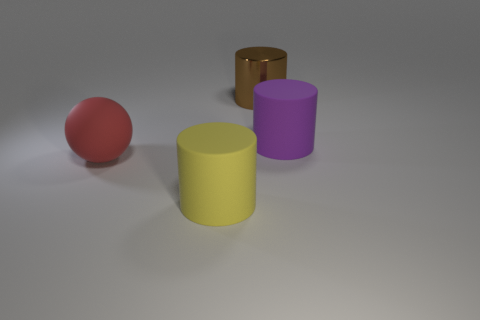Subtract all big metallic cylinders. How many cylinders are left? 2 Add 2 brown metal cylinders. How many objects exist? 6 Subtract all balls. How many objects are left? 3 Subtract all brown cylinders. How many cylinders are left? 2 Subtract all green cylinders. Subtract all blue blocks. How many cylinders are left? 3 Subtract all large yellow things. Subtract all purple rubber cylinders. How many objects are left? 2 Add 1 yellow cylinders. How many yellow cylinders are left? 2 Add 1 yellow rubber things. How many yellow rubber things exist? 2 Subtract 0 green cylinders. How many objects are left? 4 